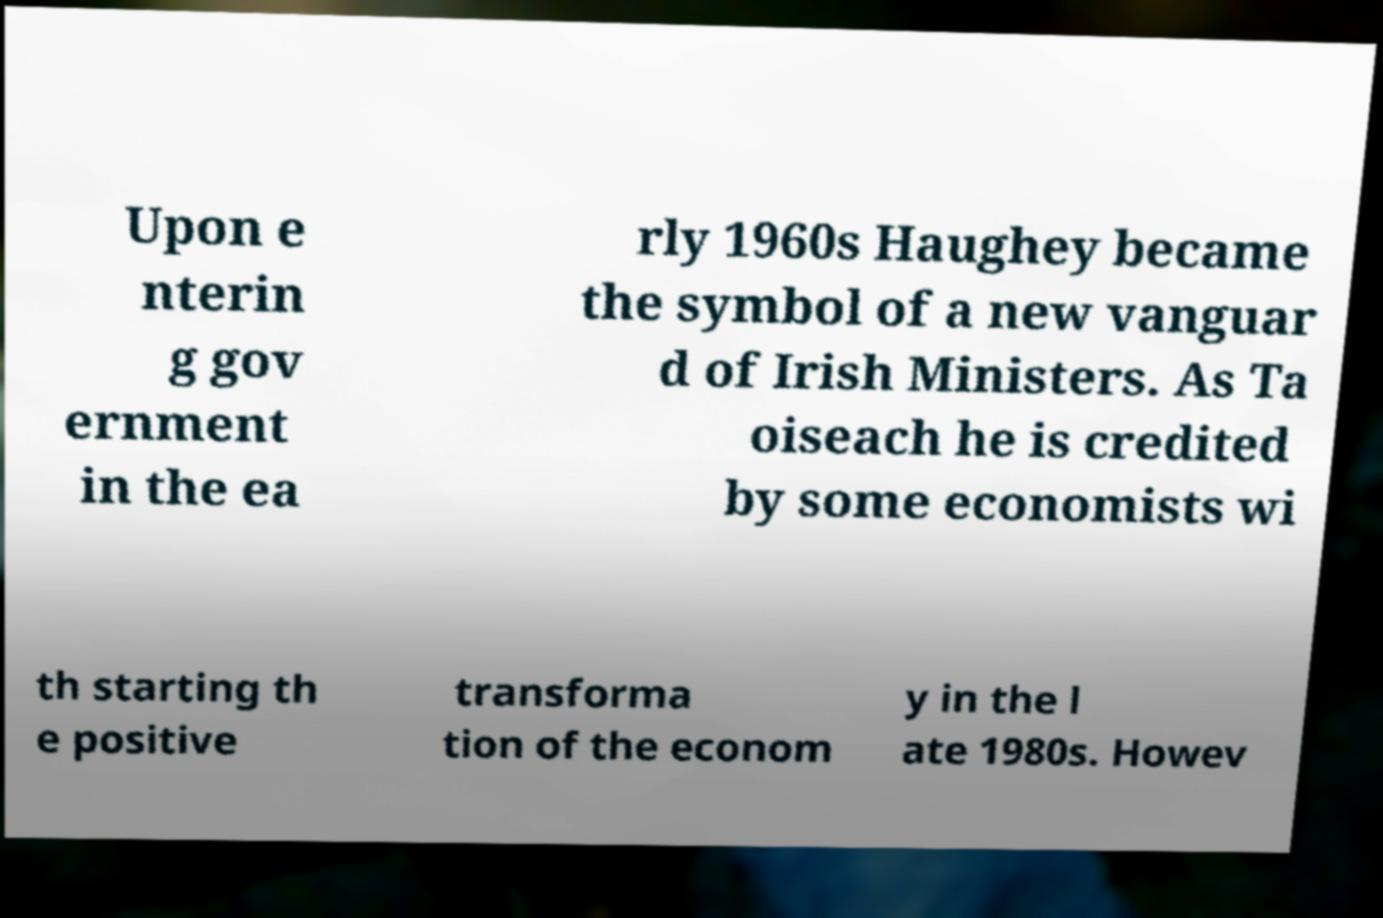For documentation purposes, I need the text within this image transcribed. Could you provide that? Upon e nterin g gov ernment in the ea rly 1960s Haughey became the symbol of a new vanguar d of Irish Ministers. As Ta oiseach he is credited by some economists wi th starting th e positive transforma tion of the econom y in the l ate 1980s. Howev 